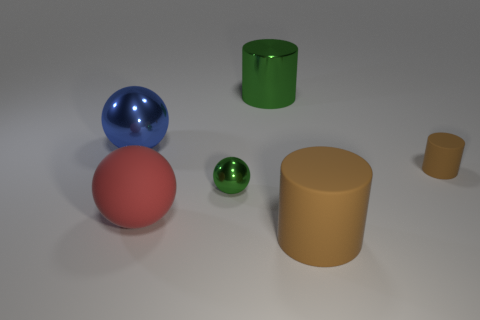Can you describe the texture of the surfaces that the objects are resting on? The surface on which the objects rest appears to be relatively smooth with a slight speckle pattern, which gives it a subtle texture. The matte finish suggests it might be a form of untreated or minimally treated material. The environment lacks strong reflections or any obvious texture details, further hinting that it serves as a neutral ground to highlight the objects themselves. 